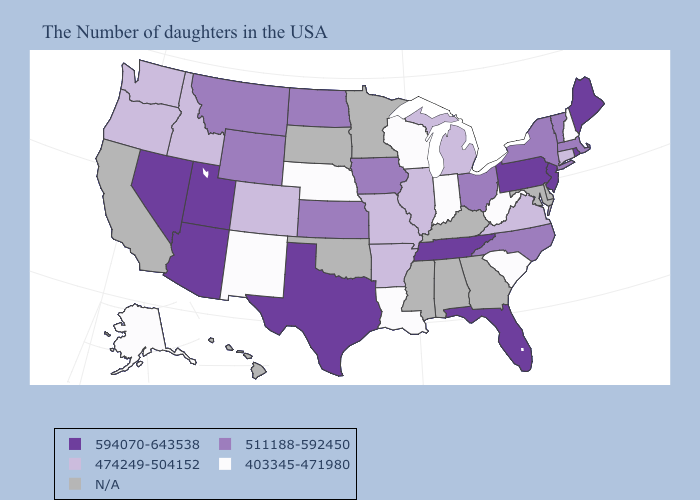What is the highest value in the USA?
Write a very short answer. 594070-643538. What is the value of North Dakota?
Quick response, please. 511188-592450. Name the states that have a value in the range 511188-592450?
Be succinct. Massachusetts, Vermont, New York, North Carolina, Ohio, Iowa, Kansas, North Dakota, Wyoming, Montana. Which states have the highest value in the USA?
Give a very brief answer. Maine, Rhode Island, New Jersey, Pennsylvania, Florida, Tennessee, Texas, Utah, Arizona, Nevada. What is the highest value in states that border Wyoming?
Be succinct. 594070-643538. Name the states that have a value in the range N/A?
Answer briefly. Delaware, Maryland, Georgia, Kentucky, Alabama, Mississippi, Minnesota, Oklahoma, South Dakota, California, Hawaii. Is the legend a continuous bar?
Be succinct. No. Which states have the highest value in the USA?
Short answer required. Maine, Rhode Island, New Jersey, Pennsylvania, Florida, Tennessee, Texas, Utah, Arizona, Nevada. What is the value of Colorado?
Short answer required. 474249-504152. Which states have the lowest value in the West?
Concise answer only. New Mexico, Alaska. Does Illinois have the lowest value in the USA?
Give a very brief answer. No. What is the value of Kansas?
Give a very brief answer. 511188-592450. Is the legend a continuous bar?
Answer briefly. No. Among the states that border Oregon , does Washington have the lowest value?
Keep it brief. Yes. 